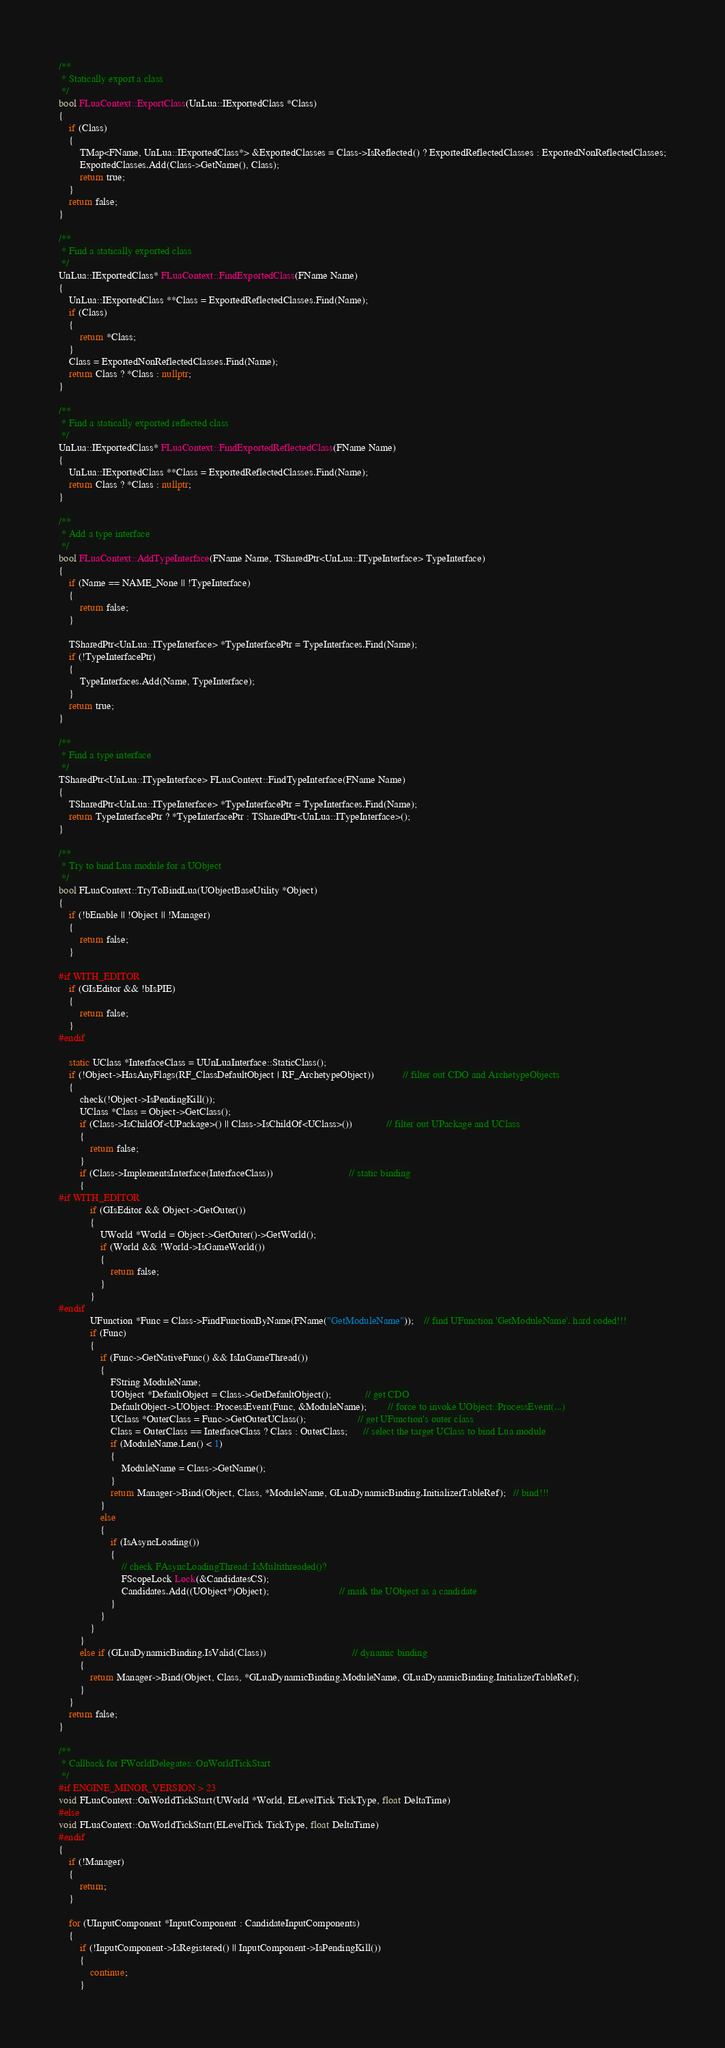<code> <loc_0><loc_0><loc_500><loc_500><_C++_>/**
 * Statically export a class
 */
bool FLuaContext::ExportClass(UnLua::IExportedClass *Class)
{
    if (Class)
    {
        TMap<FName, UnLua::IExportedClass*> &ExportedClasses = Class->IsReflected() ? ExportedReflectedClasses : ExportedNonReflectedClasses;
        ExportedClasses.Add(Class->GetName(), Class);
        return true;
    }
    return false;
}

/**
 * Find a statically exported class
 */
UnLua::IExportedClass* FLuaContext::FindExportedClass(FName Name)
{
    UnLua::IExportedClass **Class = ExportedReflectedClasses.Find(Name);
    if (Class)
    {
        return *Class;
    }
    Class = ExportedNonReflectedClasses.Find(Name);
    return Class ? *Class : nullptr;
}

/**
 * Find a statically exported reflected class
 */
UnLua::IExportedClass* FLuaContext::FindExportedReflectedClass(FName Name)
{
    UnLua::IExportedClass **Class = ExportedReflectedClasses.Find(Name);
    return Class ? *Class : nullptr;
}

/**
 * Add a type interface
 */
bool FLuaContext::AddTypeInterface(FName Name, TSharedPtr<UnLua::ITypeInterface> TypeInterface)
{
    if (Name == NAME_None || !TypeInterface)
    {
        return false;
    }

    TSharedPtr<UnLua::ITypeInterface> *TypeInterfacePtr = TypeInterfaces.Find(Name);
    if (!TypeInterfacePtr)
    {
        TypeInterfaces.Add(Name, TypeInterface);
    }
    return true;
}

/**
 * Find a type interface
 */
TSharedPtr<UnLua::ITypeInterface> FLuaContext::FindTypeInterface(FName Name)
{
    TSharedPtr<UnLua::ITypeInterface> *TypeInterfacePtr = TypeInterfaces.Find(Name);
    return TypeInterfacePtr ? *TypeInterfacePtr : TSharedPtr<UnLua::ITypeInterface>();
}

/**
 * Try to bind Lua module for a UObject
 */
bool FLuaContext::TryToBindLua(UObjectBaseUtility *Object)
{
    if (!bEnable || !Object || !Manager)
    {
        return false;
    }

#if WITH_EDITOR
    if (GIsEditor && !bIsPIE)
    {
        return false;
    }
#endif

    static UClass *InterfaceClass = UUnLuaInterface::StaticClass();
    if (!Object->HasAnyFlags(RF_ClassDefaultObject | RF_ArchetypeObject))           // filter out CDO and ArchetypeObjects
    {
        check(!Object->IsPendingKill());
        UClass *Class = Object->GetClass();
        if (Class->IsChildOf<UPackage>() || Class->IsChildOf<UClass>())             // filter out UPackage and UClass
        {
            return false;
        }
        if (Class->ImplementsInterface(InterfaceClass))                             // static binding
        {
#if WITH_EDITOR
            if (GIsEditor && Object->GetOuter())
            {
                UWorld *World = Object->GetOuter()->GetWorld();
                if (World && !World->IsGameWorld())
                {
                    return false;
                }
            }
#endif
            UFunction *Func = Class->FindFunctionByName(FName("GetModuleName"));    // find UFunction 'GetModuleName'. hard coded!!!
            if (Func)
            {
                if (Func->GetNativeFunc() && IsInGameThread())
                {
                    FString ModuleName;
                    UObject *DefaultObject = Class->GetDefaultObject();             // get CDO
                    DefaultObject->UObject::ProcessEvent(Func, &ModuleName);        // force to invoke UObject::ProcessEvent(...)
                    UClass *OuterClass = Func->GetOuterUClass();                    // get UFunction's outer class
                    Class = OuterClass == InterfaceClass ? Class : OuterClass;      // select the target UClass to bind Lua module
                    if (ModuleName.Len() < 1)
                    {
                        ModuleName = Class->GetName();
                    }
                    return Manager->Bind(Object, Class, *ModuleName, GLuaDynamicBinding.InitializerTableRef);   // bind!!!
                }
                else
                {
                    if (IsAsyncLoading())
                    {
                        // check FAsyncLoadingThread::IsMultithreaded()?
                        FScopeLock Lock(&CandidatesCS);
                        Candidates.Add((UObject*)Object);                           // mark the UObject as a candidate
                    }
                }
            }
        }
        else if (GLuaDynamicBinding.IsValid(Class))                                 // dynamic binding
        {
            return Manager->Bind(Object, Class, *GLuaDynamicBinding.ModuleName, GLuaDynamicBinding.InitializerTableRef);
        }
    }
    return false;
}

/**
 * Callback for FWorldDelegates::OnWorldTickStart
 */
#if ENGINE_MINOR_VERSION > 23
void FLuaContext::OnWorldTickStart(UWorld *World, ELevelTick TickType, float DeltaTime)
#else
void FLuaContext::OnWorldTickStart(ELevelTick TickType, float DeltaTime)
#endif
{
    if (!Manager)
    {
        return;
    }

    for (UInputComponent *InputComponent : CandidateInputComponents)
    {
        if (!InputComponent->IsRegistered() || InputComponent->IsPendingKill())
        {
            continue;
        }
</code> 